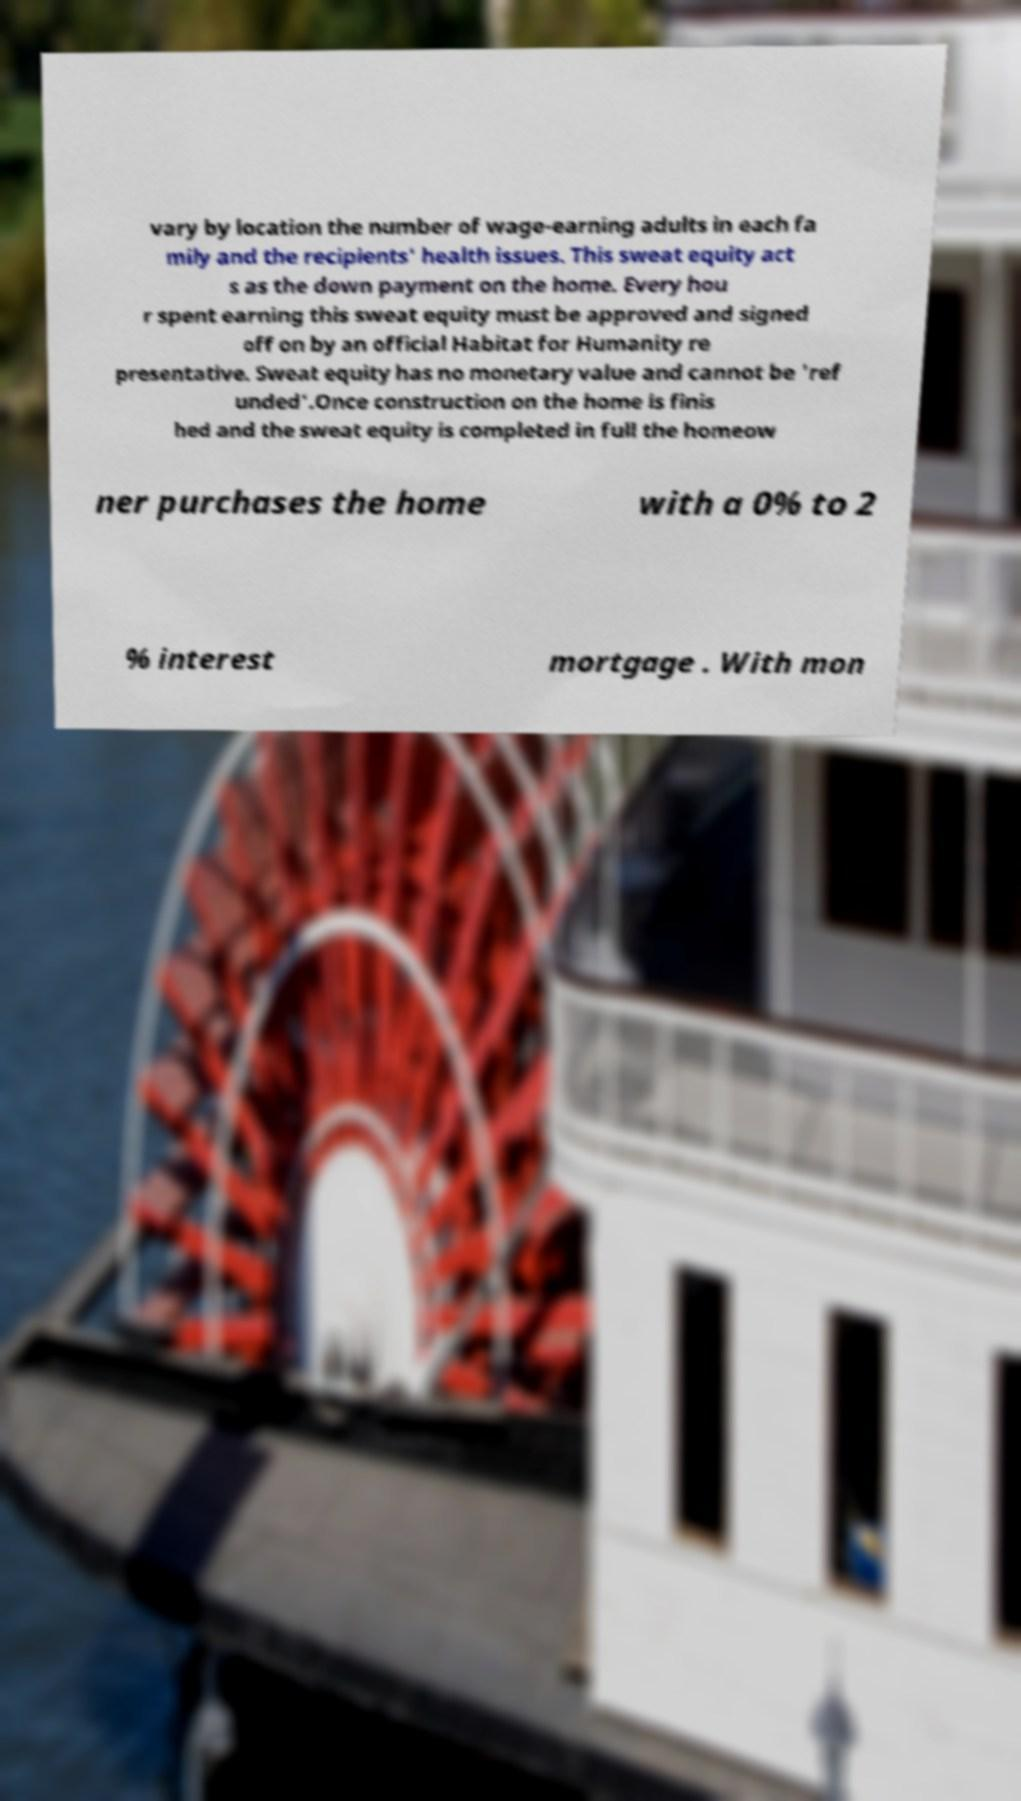Could you extract and type out the text from this image? vary by location the number of wage-earning adults in each fa mily and the recipients' health issues. This sweat equity act s as the down payment on the home. Every hou r spent earning this sweat equity must be approved and signed off on by an official Habitat for Humanity re presentative. Sweat equity has no monetary value and cannot be 'ref unded'.Once construction on the home is finis hed and the sweat equity is completed in full the homeow ner purchases the home with a 0% to 2 % interest mortgage . With mon 